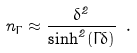<formula> <loc_0><loc_0><loc_500><loc_500>n _ { \Gamma } \approx \frac { \delta ^ { 2 } } { \sinh ^ { 2 } ( \Gamma \delta ) } \ .</formula> 